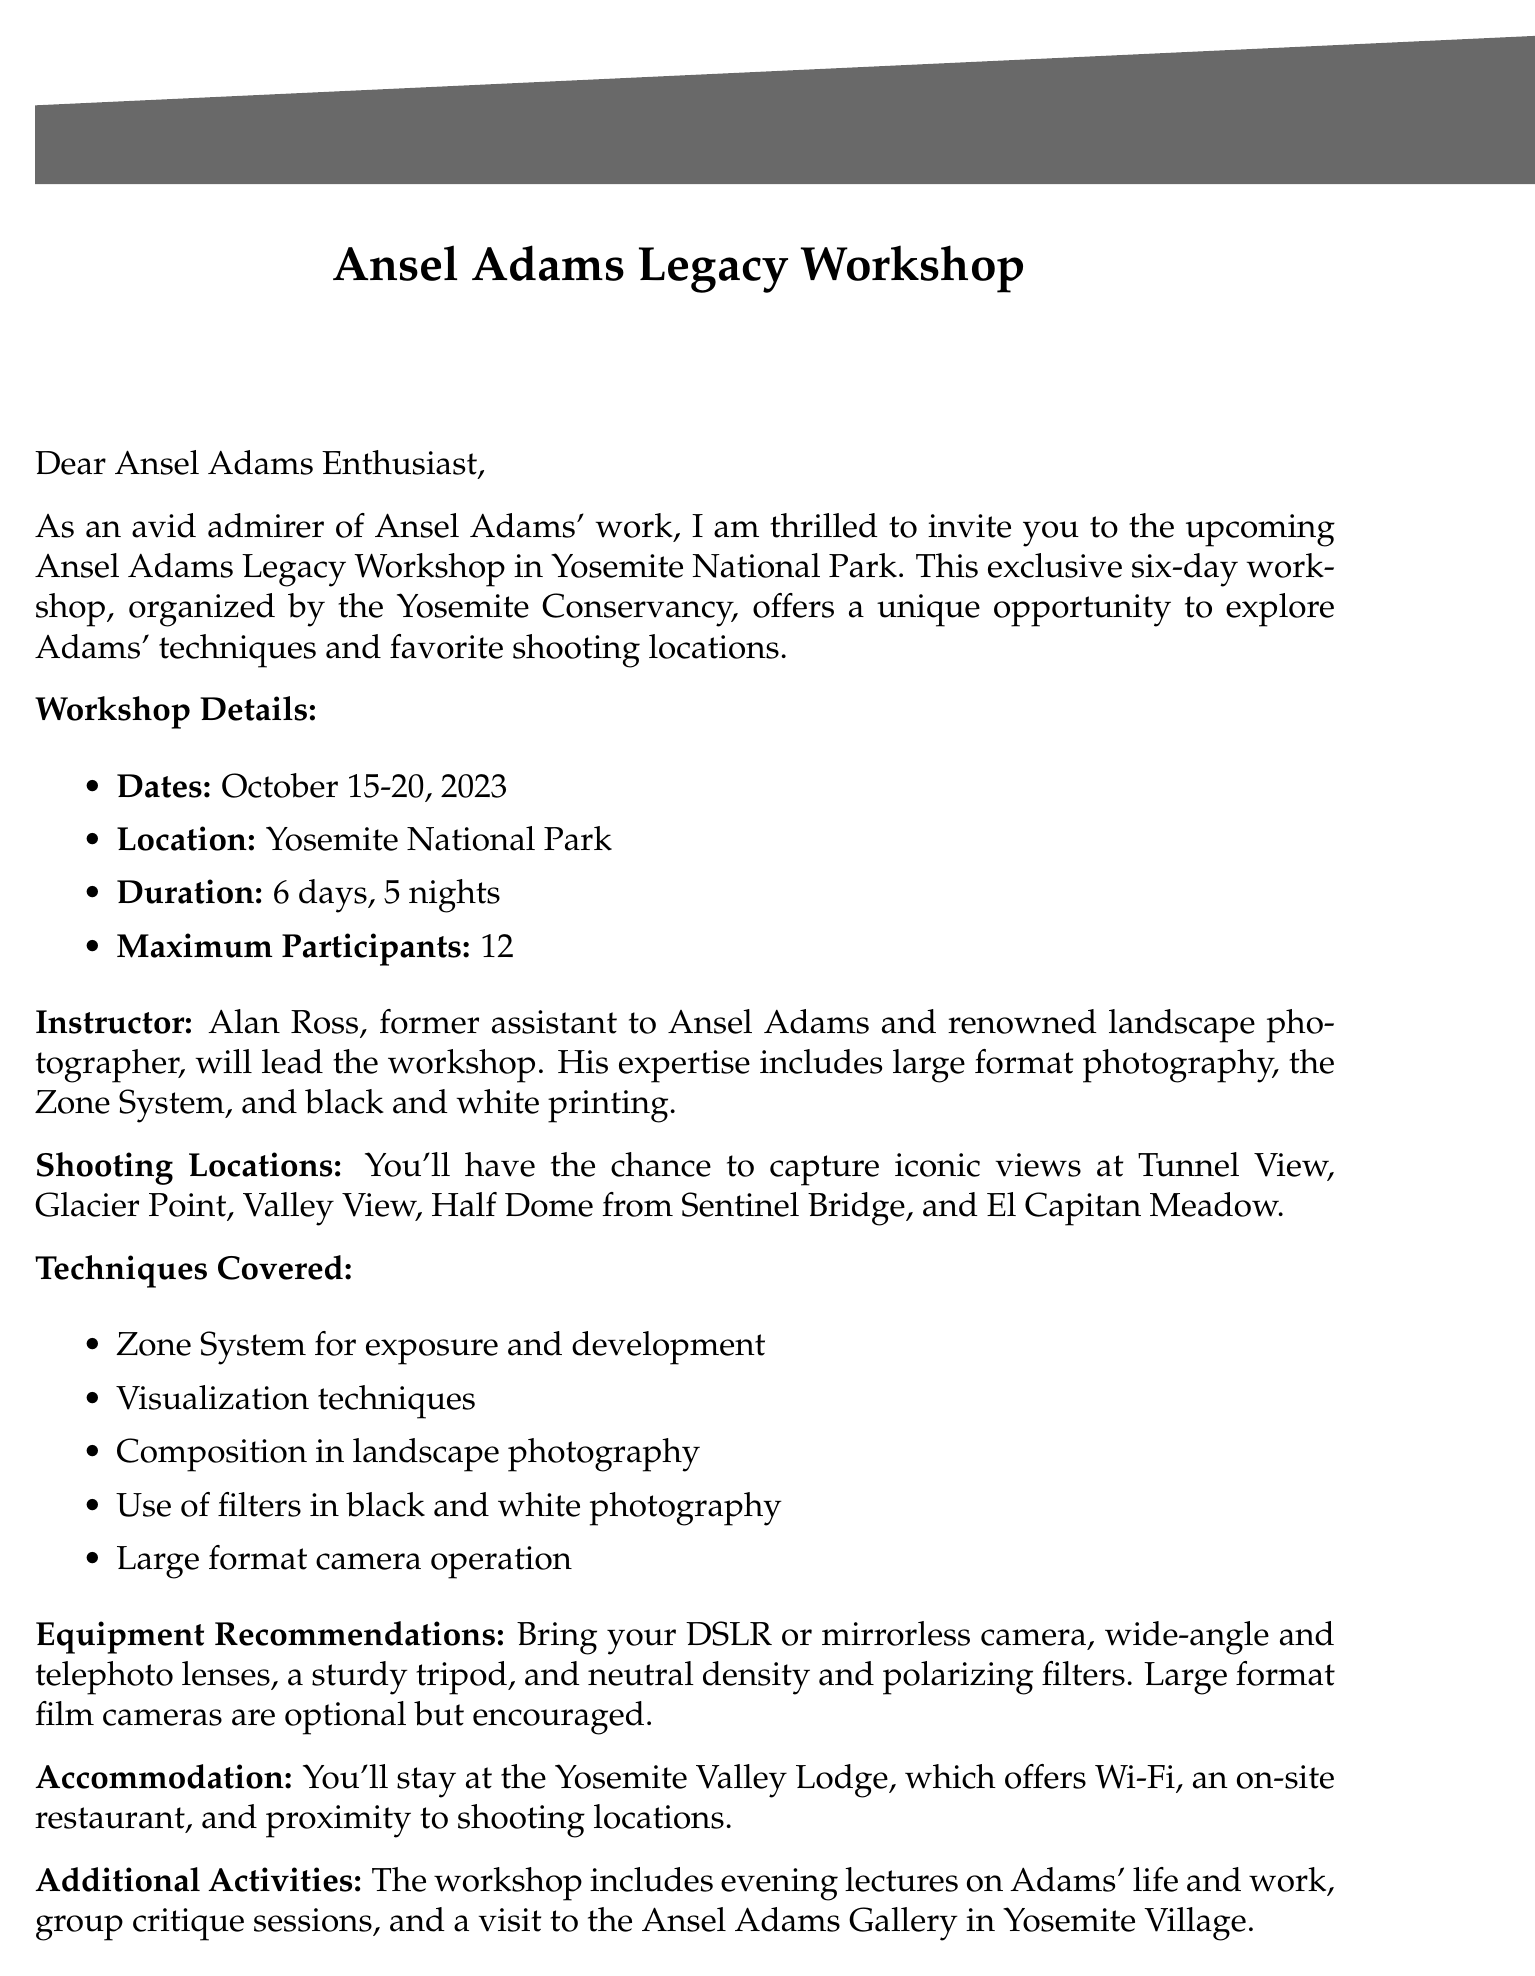What are the workshop dates? The workshop dates are explicitly mentioned in the document as October 15-20, 2023.
Answer: October 15-20, 2023 Who is the instructor? The document specifies that the instructor for the workshop is Alan Ross.
Answer: Alan Ross What is the maximum number of participants? The maximum number of participants is a specific number stated in the document, which is 12.
Answer: 12 What photographic technique is emphasized in the workshop? One of the techniques covered in the workshop, as mentioned in the document, is the Zone System for exposure and development.
Answer: Zone System Where will the accommodation be? The document indicates that accommodation will be at the Yosemite Valley Lodge.
Answer: Yosemite Valley Lodge What is included in the workshop fee? The document lists inclusions like instruction, park entrance fees, accommodation, and transportation within the park as part of the workshop fee.
Answer: Instruction, park entrance fees, accommodation, transportation within the park What are two recommended pieces of equipment? The document recommends several pieces of equipment; two mentioned are a sturdy tripod and neutral density filters.
Answer: Sturdy tripod, neutral density filters When is the registration deadline? The registration deadline is specifically stated in the document as August 31, 2023.
Answer: August 31, 2023 What is a highlight of the additional activities? One of the additional activities mentioned in the document is evening lectures on Adams' life and work.
Answer: Evening lectures on Adams' life and work 